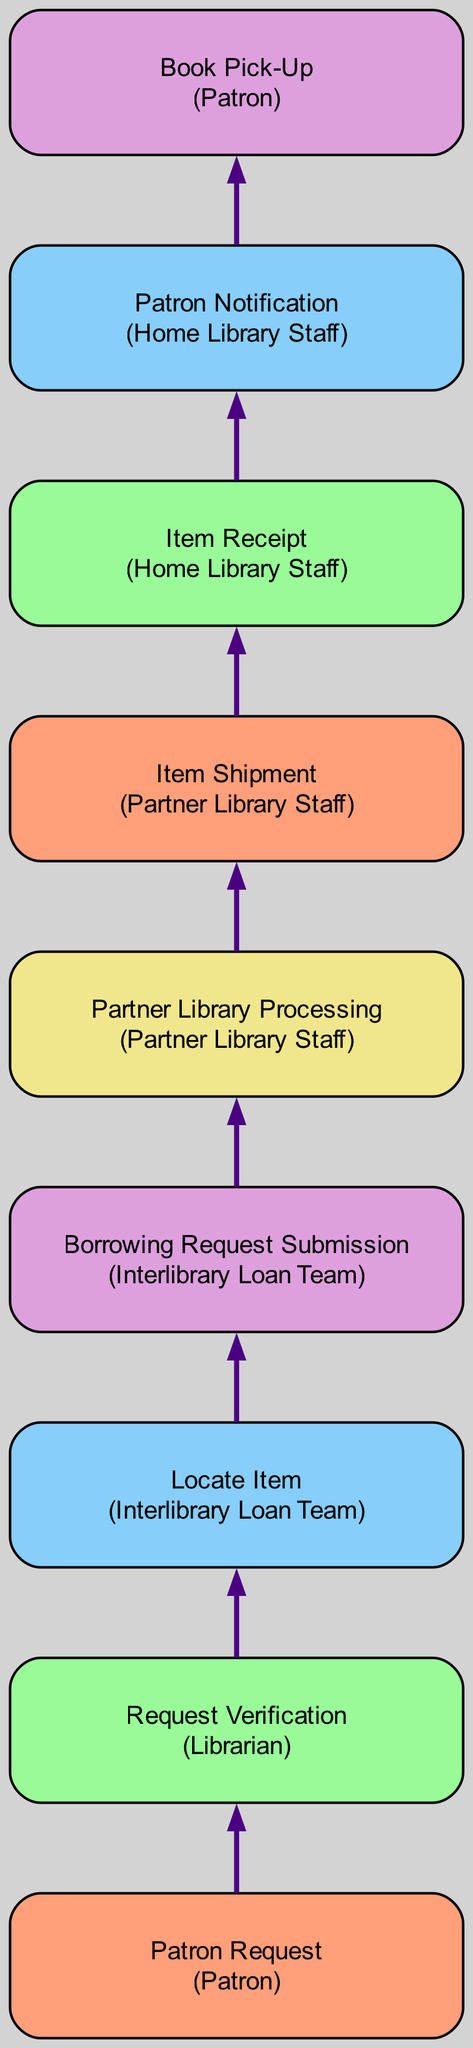What is the first node in the flow? The first node in the flow is labeled "Patron Request," indicating that the process starts when a patron submits a request.
Answer: Patron Request How many nodes are in the diagram? Counting all the distinct nodes from the Patron Request to Book Pick-Up, there are a total of 9 nodes.
Answer: 9 What role is associated with the "Request Verification" node? The "Request Verification" node is associated with the role of "Librarian," as stated in its description in the diagram.
Answer: Librarian What follows the "Item Receipt" node? The node that follows "Item Receipt" is "Patron Notification," which indicates the next step after the home library receives the shipped item.
Answer: Patron Notification How many edges connect the nodes in the flow? There are 8 edges in total, as each of the 9 nodes connects to the next one in the flow.
Answer: 8 Which node involves the "Interlibrary Loan Team" in the process? The "Borrowing Request Submission" node involves the "Interlibrary Loan Team," as they are responsible for submitting requests to partner libraries.
Answer: Borrowing Request Submission What is the last node in the flow? The last node in the flow is "Book Pick-Up," which indicates the completion of the process when the patron collects the book.
Answer: Book Pick-Up Which role is responsible for shipping the item? The role responsible for shipping the item is "Partner Library Staff," as noted in the "Item Shipment" node description.
Answer: Partner Library Staff What is the connection between "Locate Item" and "Partner Library Processing"? The "Locate Item" node leads to the "Borrowing Request Submission," which then connects to "Partner Library Processing," indicating a linear flow of actions for acquiring the book.
Answer: Borrowing Request Submission 